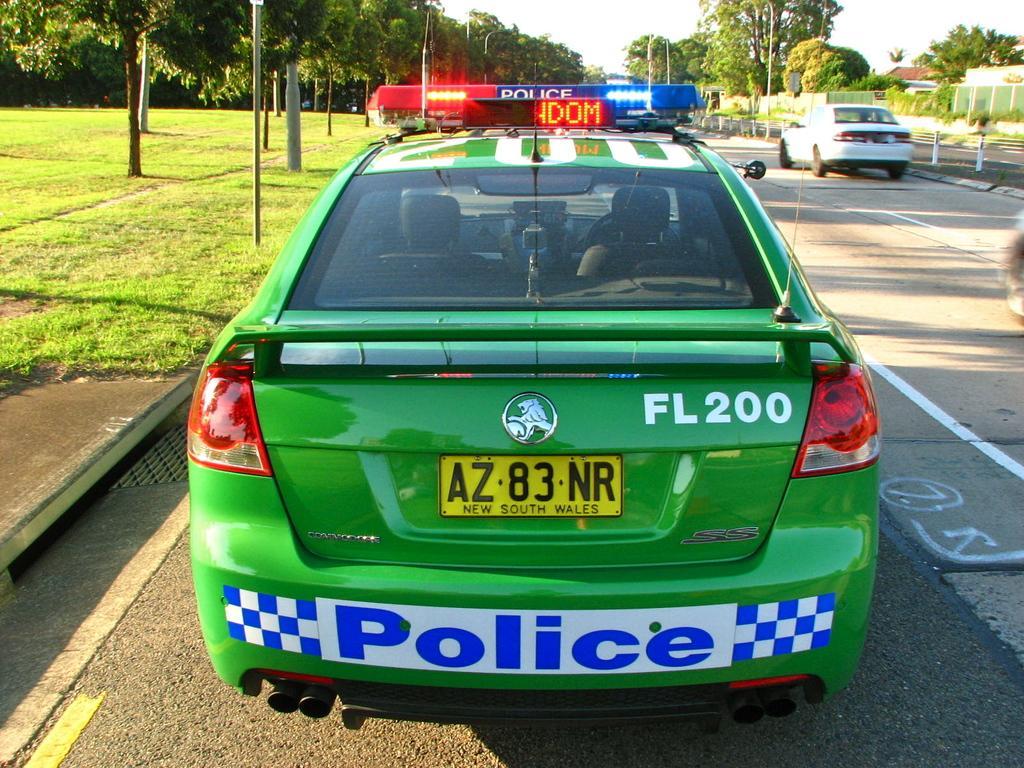How would you summarize this image in a sentence or two? In this image we can see motor vehicles on the road, street poles, street lights, buildings, trees, grass and sky. 